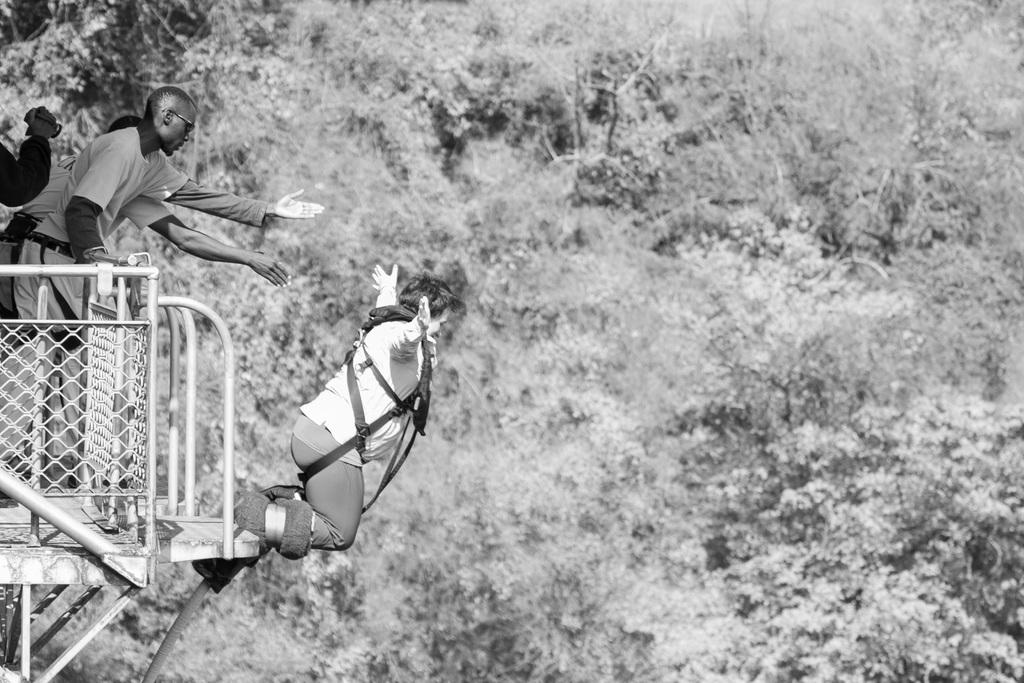What is the color scheme of the image? The image is black and white. What can be seen in the background of the image? There are trees in the background of the image. Where are the people located in the image? There are people standing to the left side of the image. What is the person in the image doing? The person is jumping in the image. What is the person wearing while jumping? The person jumping is wearing a belt. What type of calculator is being used by the person jumping in the image? There is no calculator present in the image; the person is simply jumping. What punishment is being administered to the person jumping in the image? There is no punishment being administered in the image; the person is jumping voluntarily. 